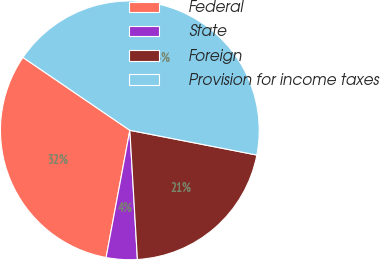Convert chart to OTSL. <chart><loc_0><loc_0><loc_500><loc_500><pie_chart><fcel>Federal<fcel>State<fcel>Foreign<fcel>Provision for income taxes<nl><fcel>31.59%<fcel>3.87%<fcel>21.01%<fcel>43.54%<nl></chart> 